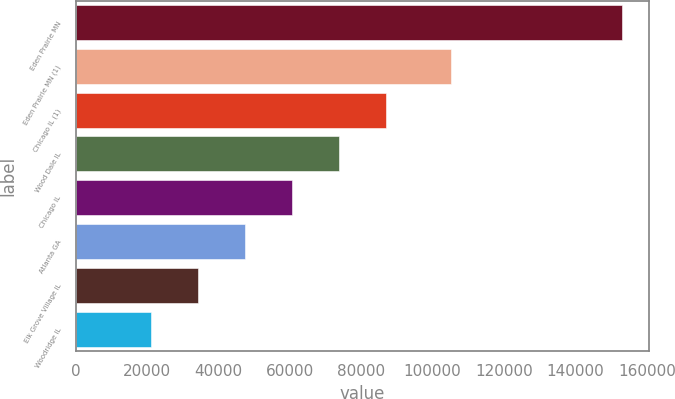<chart> <loc_0><loc_0><loc_500><loc_500><bar_chart><fcel>Eden Prairie MN<fcel>Eden Prairie MN (1)<fcel>Chicago IL (1)<fcel>Wood Dale IL<fcel>Chicago IL<fcel>Atlanta GA<fcel>Elk Grove Village IL<fcel>Woodridge IL<nl><fcel>153000<fcel>105000<fcel>87000<fcel>73800<fcel>60600<fcel>47400<fcel>34200<fcel>21000<nl></chart> 